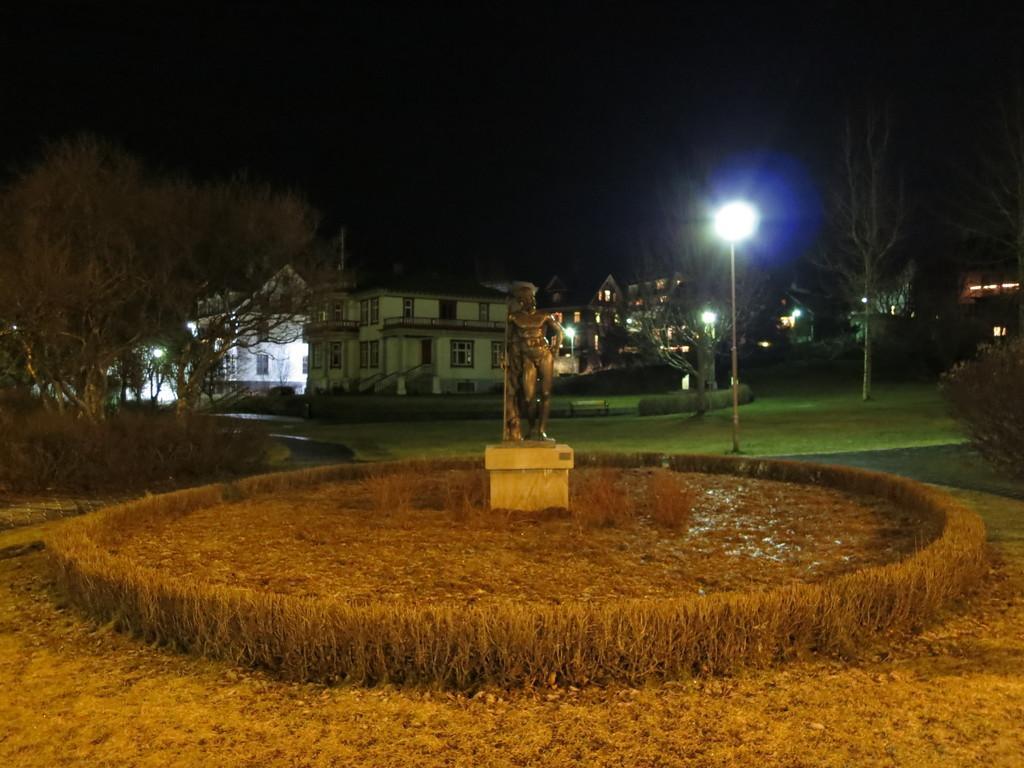Describe this image in one or two sentences. In this picture I can see there is a statue and there is grass around it. There are trees at left, few buildings and there is a walkway with poles and the sky is dark. 